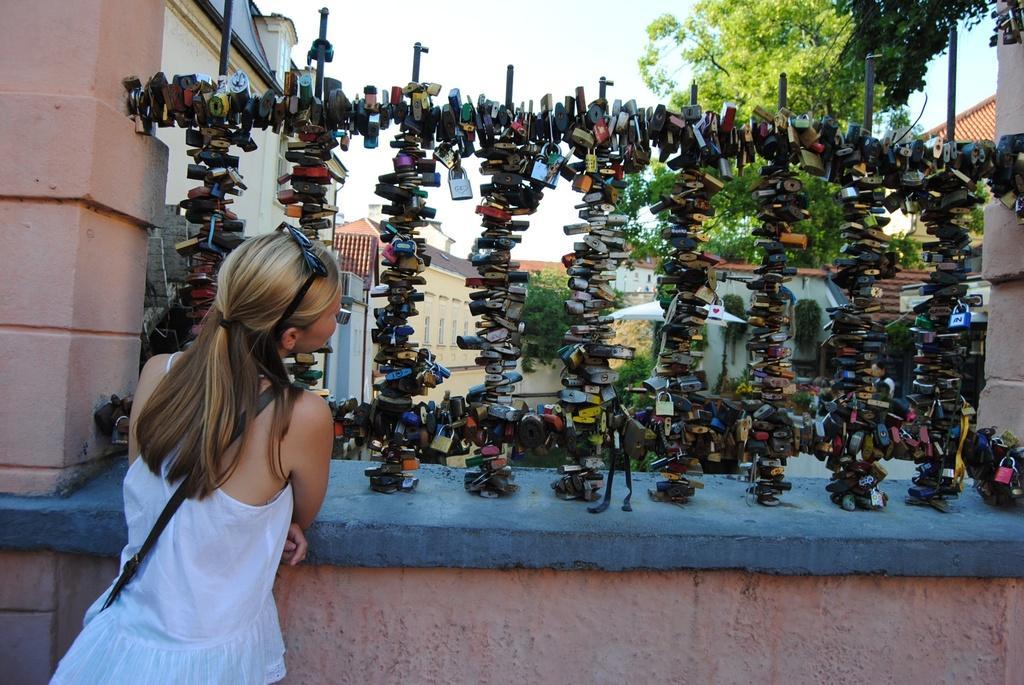Can you describe this image briefly? In this image we can see some objects attached to a stand on a wall, there we can also see a girl with goggles and holding a bag, few trees and buildings 